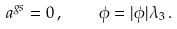Convert formula to latex. <formula><loc_0><loc_0><loc_500><loc_500>a ^ { g s } = 0 \, , \quad \phi = | \phi | \lambda _ { 3 } \, .</formula> 